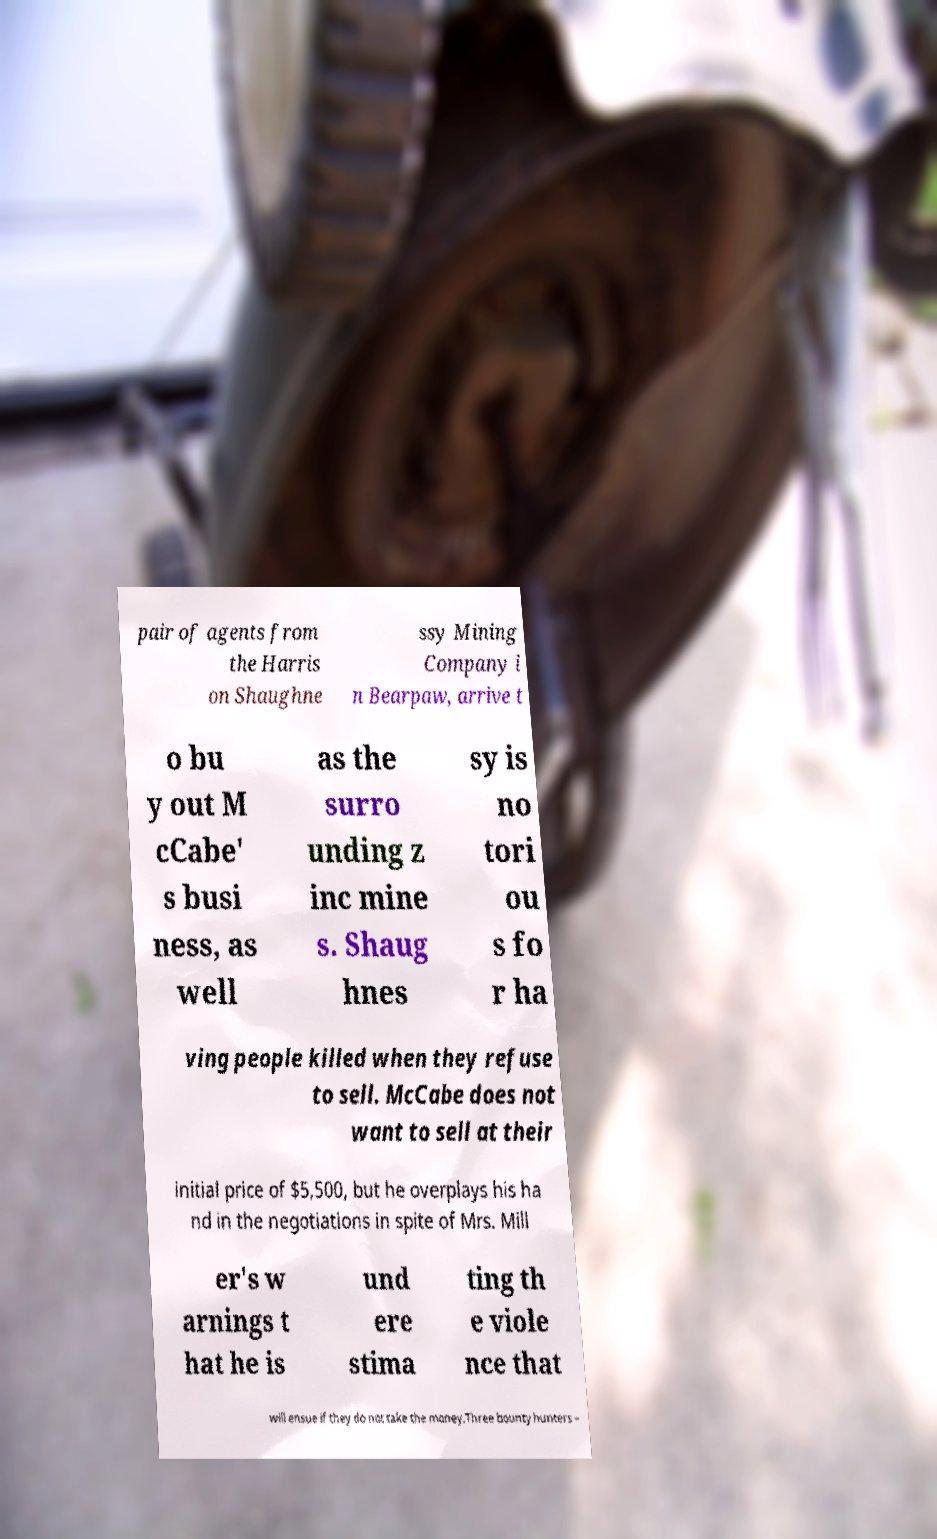Please read and relay the text visible in this image. What does it say? pair of agents from the Harris on Shaughne ssy Mining Company i n Bearpaw, arrive t o bu y out M cCabe' s busi ness, as well as the surro unding z inc mine s. Shaug hnes sy is no tori ou s fo r ha ving people killed when they refuse to sell. McCabe does not want to sell at their initial price of $5,500, but he overplays his ha nd in the negotiations in spite of Mrs. Mill er's w arnings t hat he is und ere stima ting th e viole nce that will ensue if they do not take the money.Three bounty hunters – 